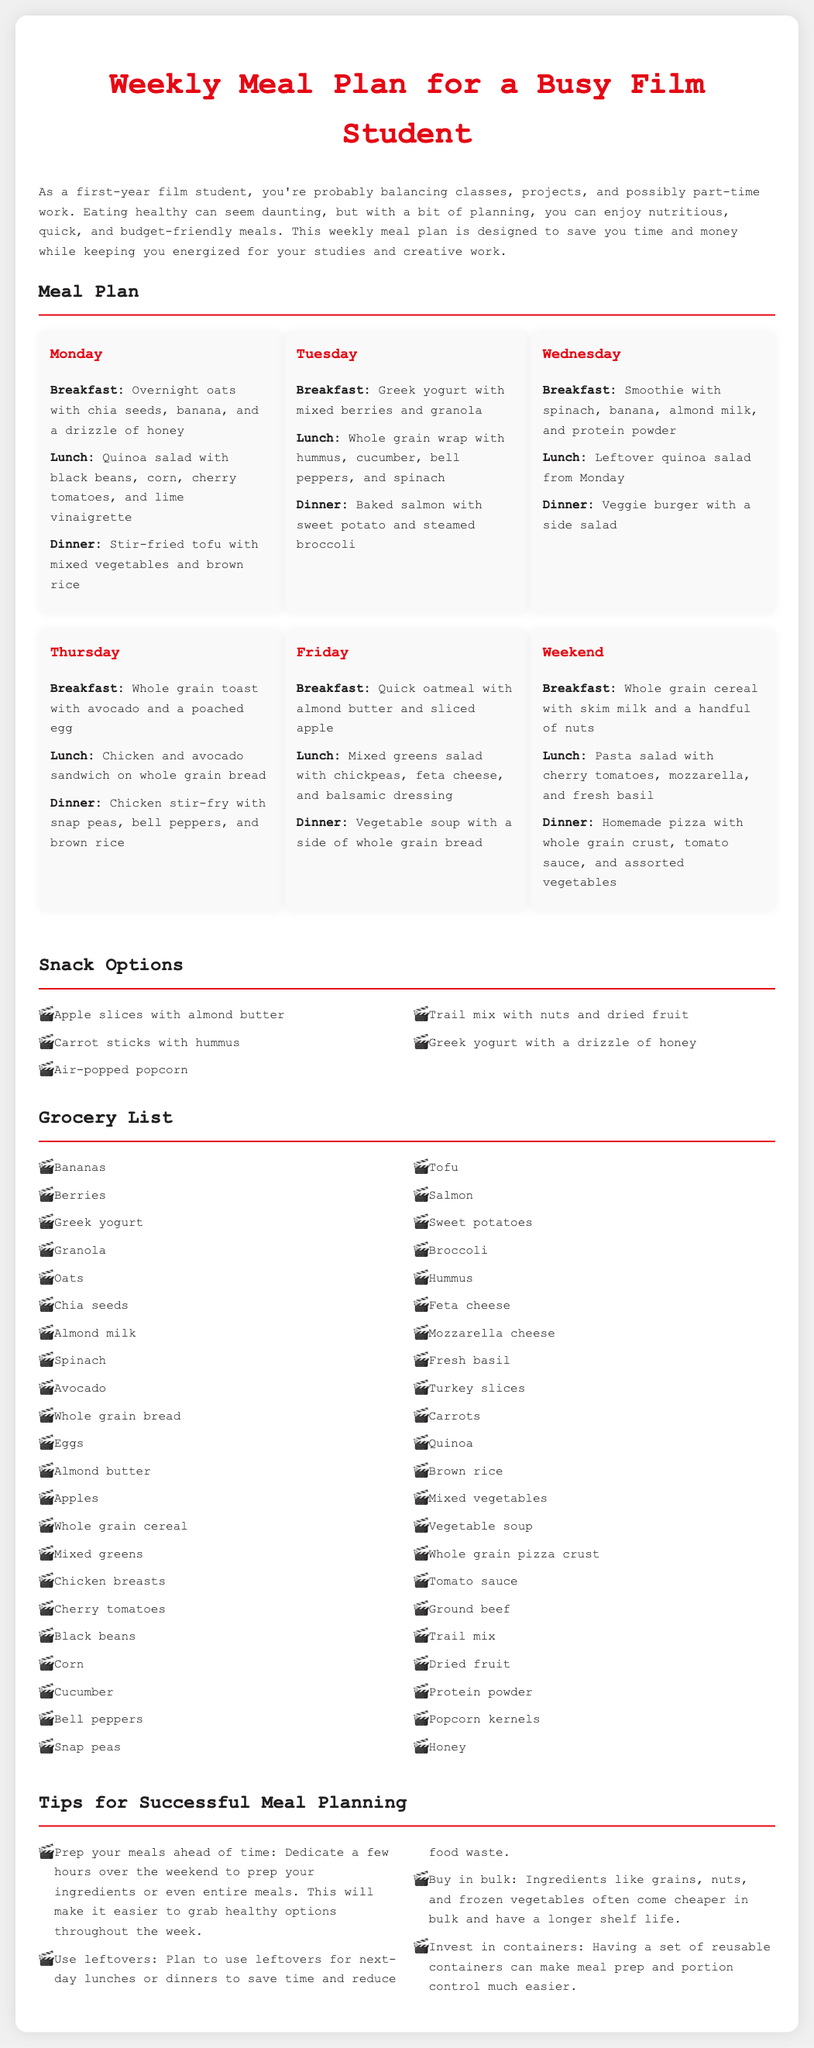What is the breakfast option for Monday? The breakfast option for Monday is listed as "Overnight oats with chia seeds, banana, and a drizzle of honey."
Answer: Overnight oats with chia seeds, banana, and a drizzle of honey How many days are included in the meal plan? The meal plan includes specific meals for six days: Monday to Friday and a weekend section.
Answer: 6 days What is a recommended snack option? One of the snack options listed is "Apple slices with almond butter."
Answer: Apple slices with almond butter Which grain is used in the salad for Tuesday's lunch? The grain used in the salad is mentioned as "quinoa," which appears in both Monday's lunch and Tuesday's salad.
Answer: Quinoa What is the main protein source in Thursday's dinner? The main protein in Thursday's dinner is "chicken," as indicated in the meal description.
Answer: Chicken What vegetable is served with baked salmon? The vegetable served with baked salmon is "steamed broccoli."
Answer: Steamed broccoli What type of bread is recommended for the chicken and avocado sandwich? The document specifies "whole grain bread" as the type for the sandwich.
Answer: Whole grain bread How can meal prep issues be alleviated according to the tips? One of the tips suggests that dedicating a few hours over the weekend to prep your ingredients can alleviate meal prep issues.
Answer: Prep ingredients ahead of time 